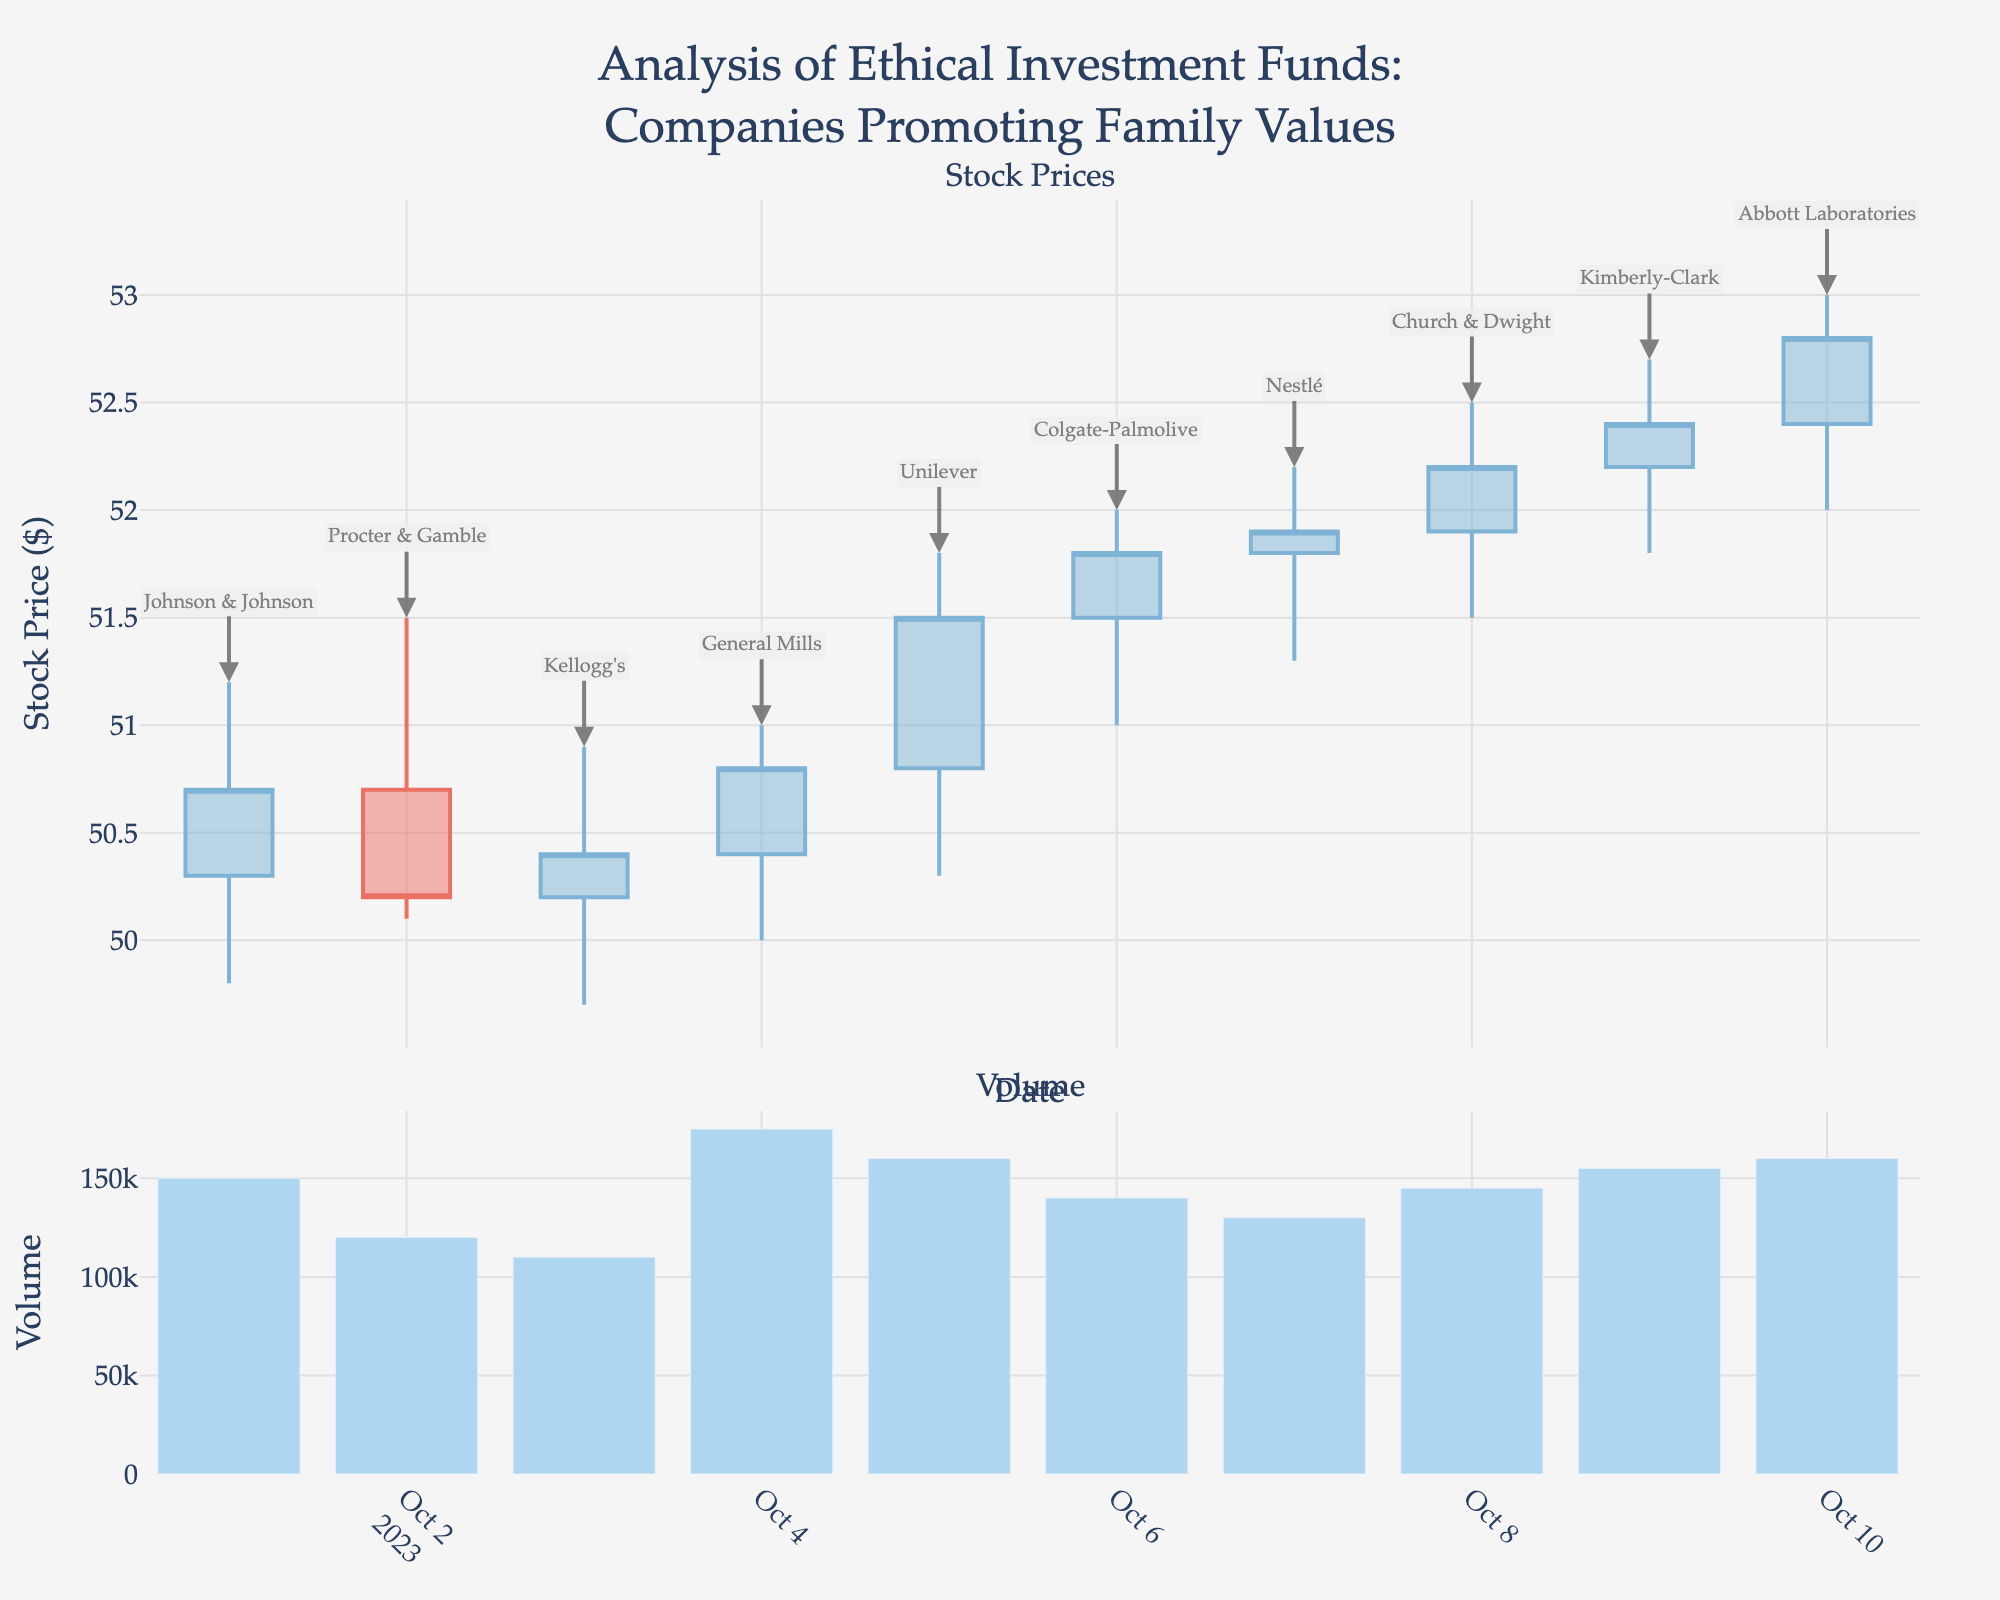What is the highest stock price recorded in the given date range? The highest stock price can be found by inspecting the 'High' values for all dates in the figure. On October 10th, the stock price reached $53.00, which is the highest in the given range.
Answer: $53.00 Which company closed at the highest price on October 6th? The figure displays the closing prices for each date. On October 6th, the closing price for Colgate-Palmolive was $51.80, making it the highest closing price on that date.
Answer: Colgate-Palmolive How does the volume on October 4th compare to the volume on October 7th? To compare volumes, look at the bar chart section of the figure. On October 4th, the volume was 175,000, while on October 7th, it was 130,000. Therefore, the volume on October 4th was higher than on October 7th.
Answer: Higher on October 4th What is the overall trend in the stock prices from October 1st to October 10th? By observing the candlestick plot, the stock prices show a general upward trend from October 1st, starting at $50.30, and closing at $52.80 on October 10th.
Answer: Upward trend Which day had the largest difference between the highest and lowest stock prices? The largest difference can be calculated by subtracting the lowest price from the highest price for each day. The largest difference occurs on October 10th, where the difference is $53.00 - $52.00 = $1.00.
Answer: October 10th Among the given dates, which day had the smallest closing price? The candlestick plot shows the closing prices for each date. The smallest closing price occurred on October 2nd, where the price closed at $50.20.
Answer: October 2nd Which company had the highest volume on a single day, and what was the volume? By examining the volume bar chart, we see that General Mills had the highest volume on October 4th with a volume of 175,000.
Answer: General Mills, 175,000 What is the average closing price of the stocks over the given period? Add all the closing prices and divide by the number of days: (50.70 + 50.20 + 50.40 + 50.80 + 51.50 + 51.80 + 51.90 + 52.20 + 52.40 + 52.80) / 10 = 51.17
Answer: 51.17 On which day did Johnson & Johnson have its stock price shown, and what were the highest and lowest prices on that day? The figure shows Johnson & Johnson's stock prices on October 1st. The highest price is $51.20, and the lowest price is $49.80.
Answer: October 1st; Highest: $51.20, Lowest: $49.80 What is the range of stock prices (difference between highest and lowest) for the entire period? To find the range, identify the overall highest and lowest prices in the period. The highest price is $53.00 (October 10th), and the lowest is $49.70 (October 3rd). The range is $53.00 - $49.70 = $3.30.
Answer: $3.30 